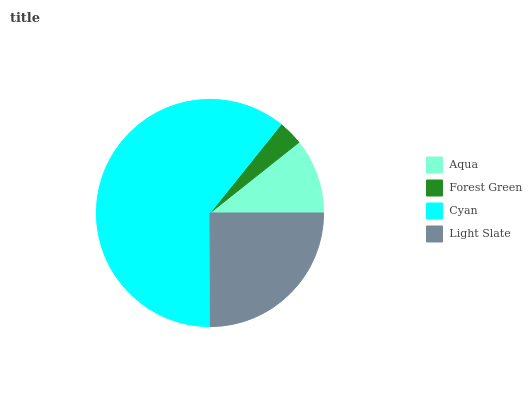Is Forest Green the minimum?
Answer yes or no. Yes. Is Cyan the maximum?
Answer yes or no. Yes. Is Cyan the minimum?
Answer yes or no. No. Is Forest Green the maximum?
Answer yes or no. No. Is Cyan greater than Forest Green?
Answer yes or no. Yes. Is Forest Green less than Cyan?
Answer yes or no. Yes. Is Forest Green greater than Cyan?
Answer yes or no. No. Is Cyan less than Forest Green?
Answer yes or no. No. Is Light Slate the high median?
Answer yes or no. Yes. Is Aqua the low median?
Answer yes or no. Yes. Is Aqua the high median?
Answer yes or no. No. Is Cyan the low median?
Answer yes or no. No. 